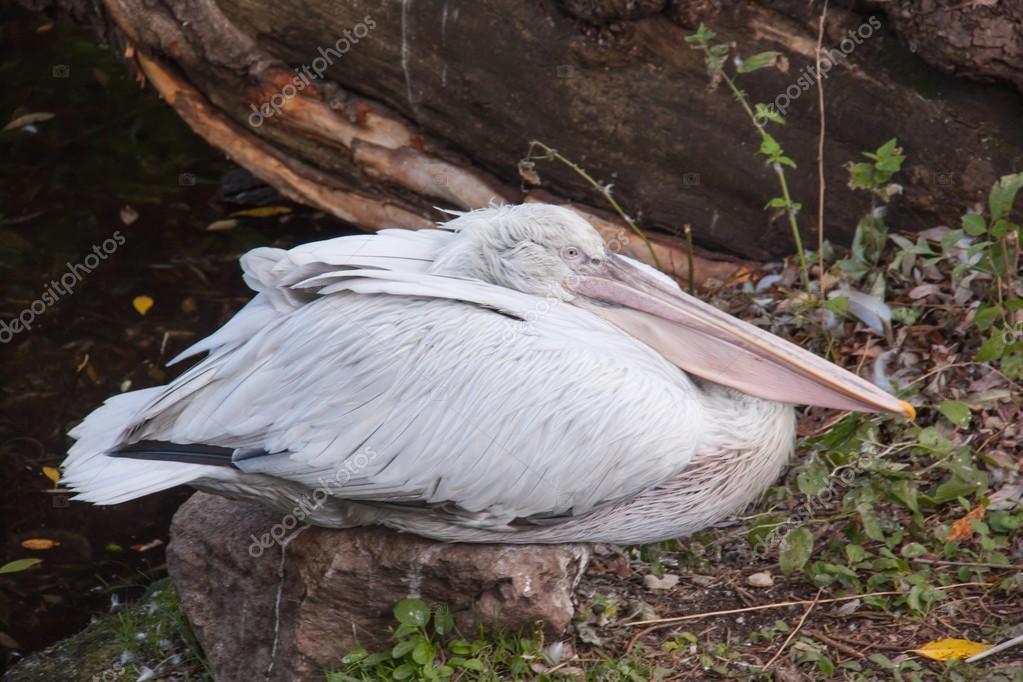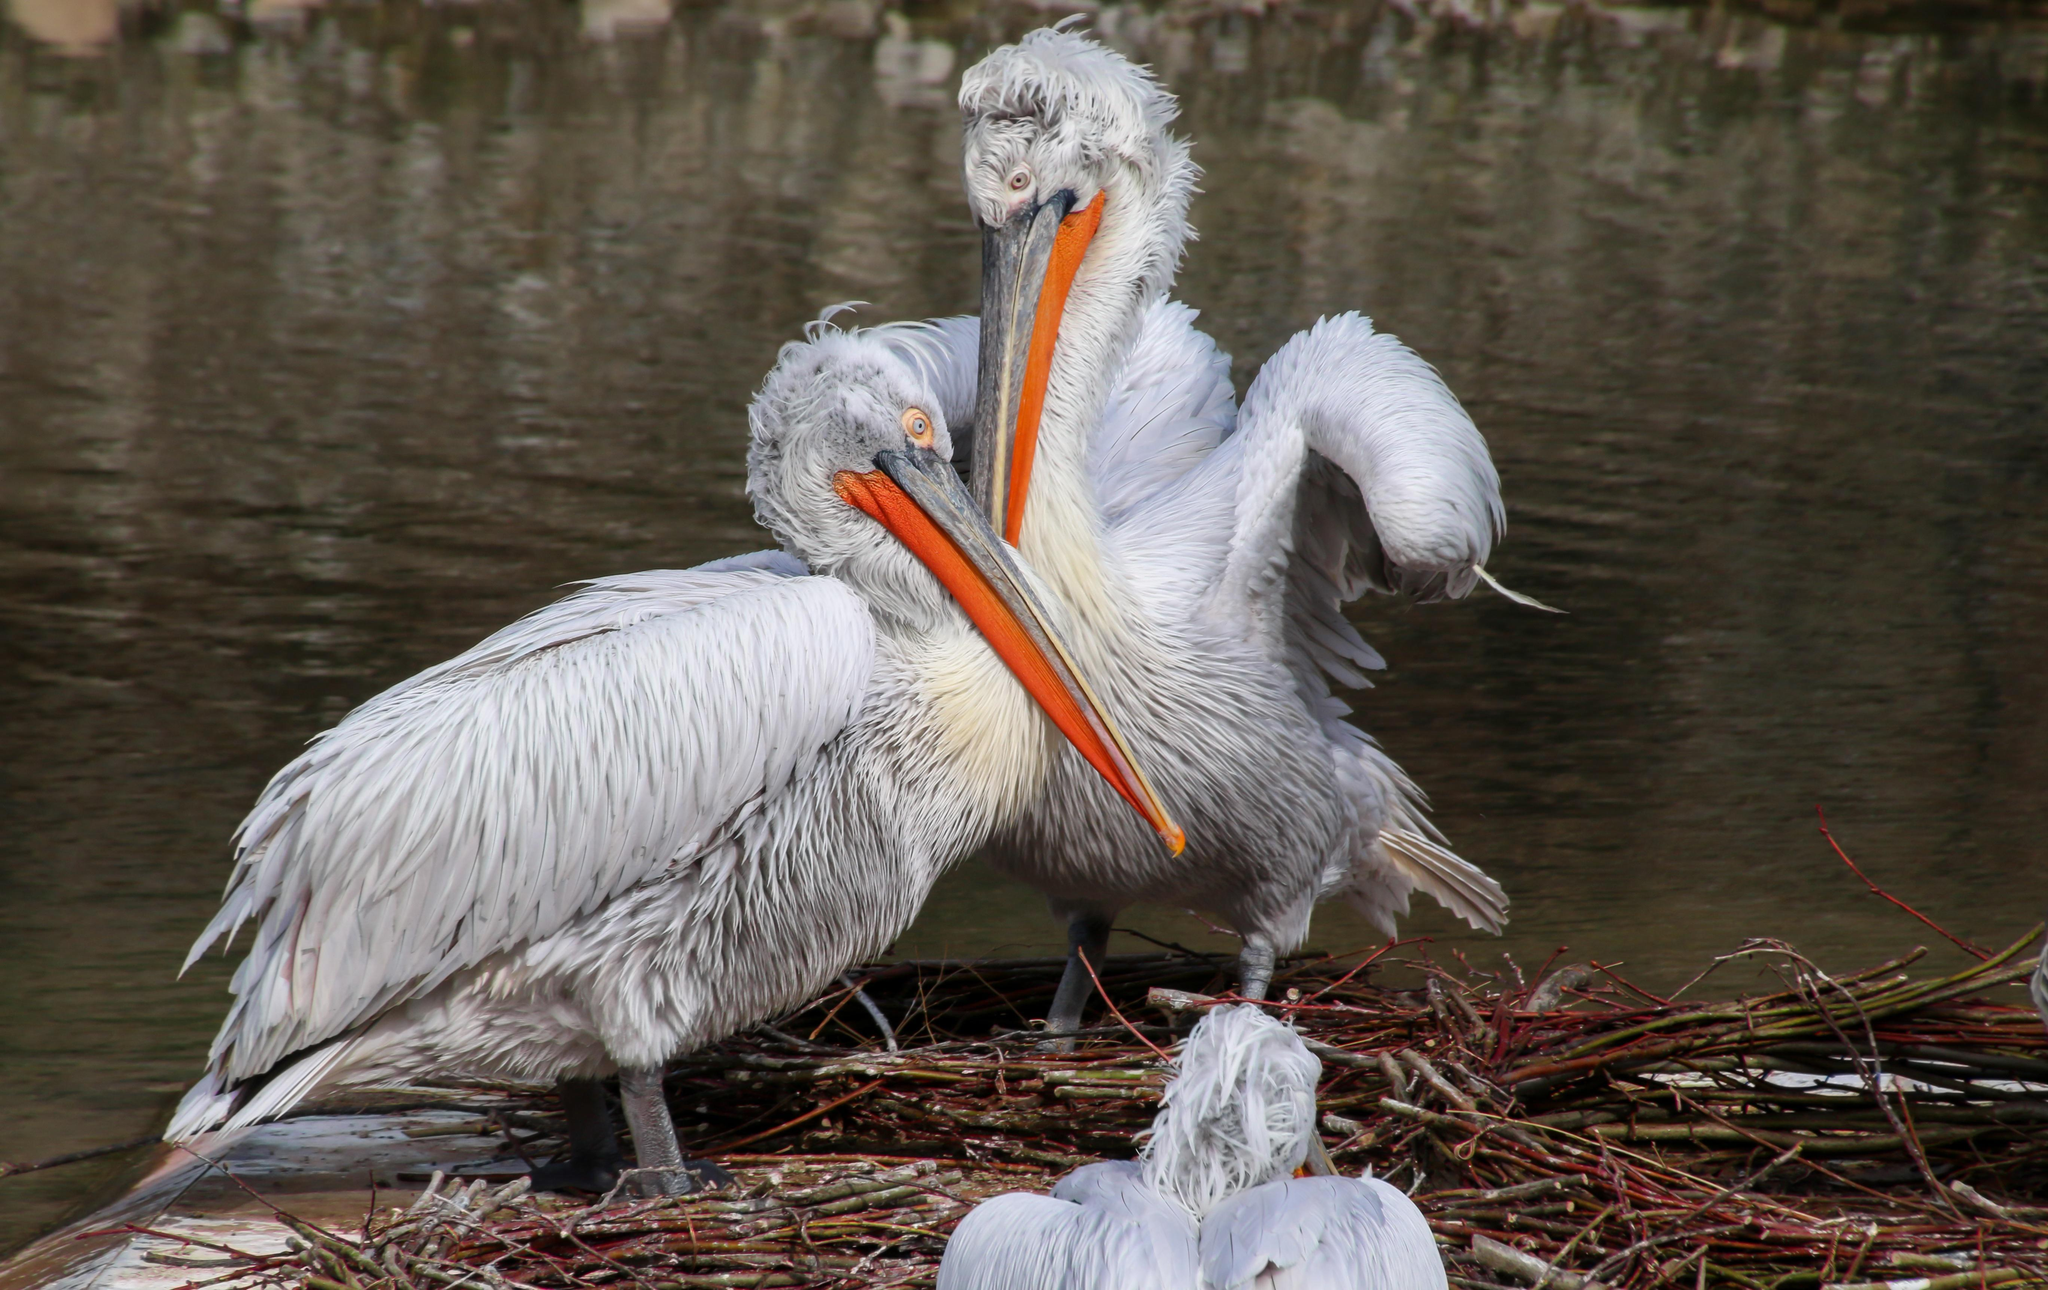The first image is the image on the left, the second image is the image on the right. Assess this claim about the two images: "One of the birds is sitting on water.". Correct or not? Answer yes or no. No. 